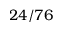<formula> <loc_0><loc_0><loc_500><loc_500>2 4 / 7 6</formula> 